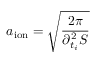Convert formula to latex. <formula><loc_0><loc_0><loc_500><loc_500>a _ { i o n } = \sqrt { \frac { 2 \pi } { \partial _ { t _ { i } } ^ { 2 } S } }</formula> 